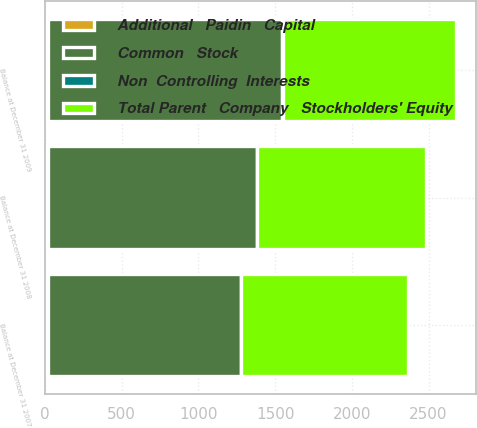Convert chart to OTSL. <chart><loc_0><loc_0><loc_500><loc_500><stacked_bar_chart><ecel><fcel>Balance at December 31 2007<fcel>Balance at December 31 2008<fcel>Balance at December 31 2009<nl><fcel>Additional   Paidin   Capital<fcel>16.8<fcel>16.8<fcel>16.9<nl><fcel>Non  Controlling  Interests<fcel>1.8<fcel>1.8<fcel>1.8<nl><fcel>Total Parent   Company   Stockholders' Equity<fcel>1086.1<fcel>1102.5<fcel>1127.1<nl><fcel>Common   Stock<fcel>1260.8<fcel>1364.3<fcel>1531.1<nl></chart> 